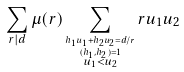<formula> <loc_0><loc_0><loc_500><loc_500>\sum _ { r | d } \mu ( r ) \sum _ { \stackrel { h _ { 1 } u _ { 1 } + h _ { 2 } u _ { 2 } = d / r } { \stackrel { ( h _ { 1 } , h _ { 2 } ) = 1 } { u _ { 1 } < u _ { 2 } } } } r u _ { 1 } u _ { 2 }</formula> 